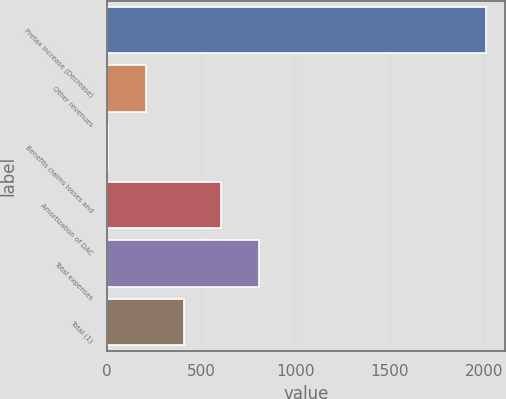<chart> <loc_0><loc_0><loc_500><loc_500><bar_chart><fcel>Pretax Increase (Decrease)<fcel>Other revenues<fcel>Benefits claims losses and<fcel>Amortization of DAC<fcel>Total expenses<fcel>Total (1)<nl><fcel>2013<fcel>205.8<fcel>5<fcel>607.4<fcel>808.2<fcel>406.6<nl></chart> 